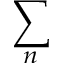Convert formula to latex. <formula><loc_0><loc_0><loc_500><loc_500>\sum _ { n }</formula> 